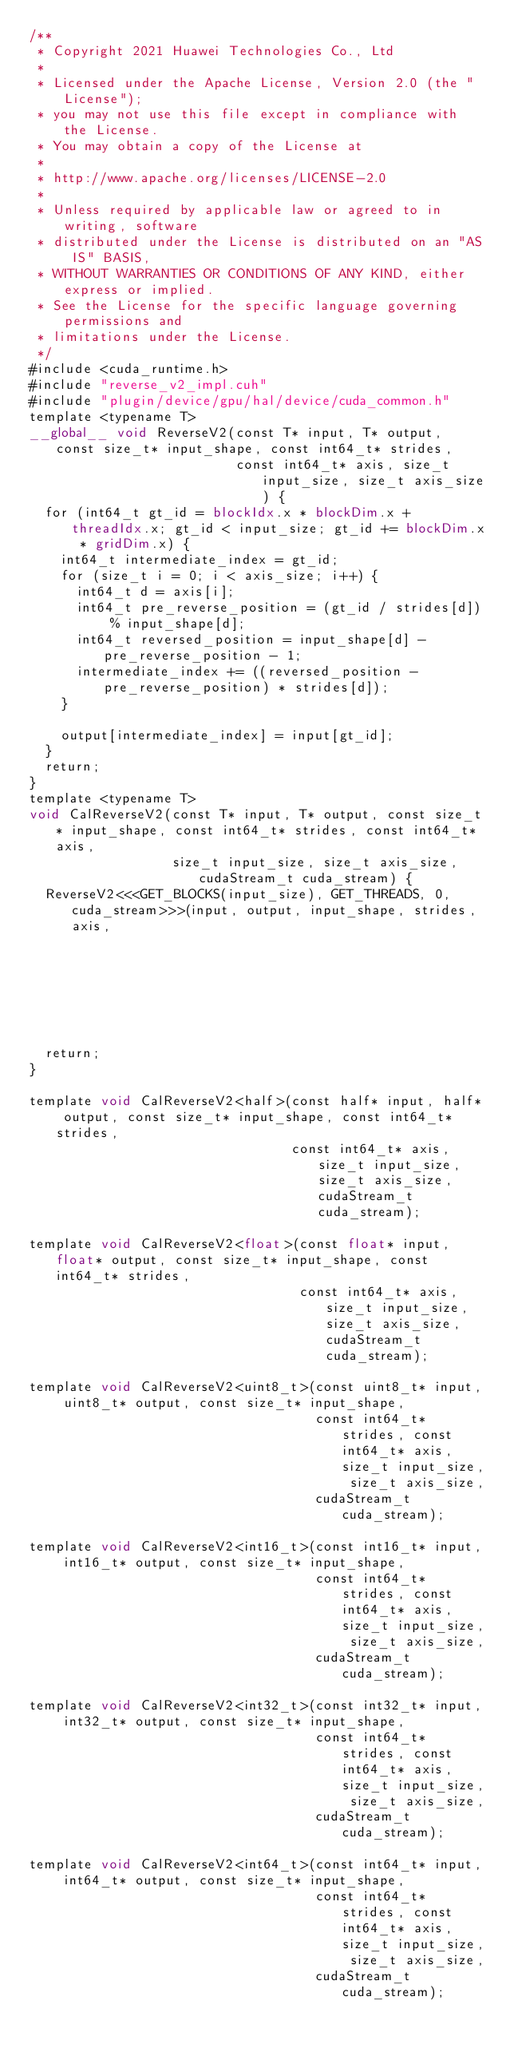Convert code to text. <code><loc_0><loc_0><loc_500><loc_500><_Cuda_>/**
 * Copyright 2021 Huawei Technologies Co., Ltd
 *
 * Licensed under the Apache License, Version 2.0 (the "License");
 * you may not use this file except in compliance with the License.
 * You may obtain a copy of the License at
 *
 * http://www.apache.org/licenses/LICENSE-2.0
 *
 * Unless required by applicable law or agreed to in writing, software
 * distributed under the License is distributed on an "AS IS" BASIS,
 * WITHOUT WARRANTIES OR CONDITIONS OF ANY KIND, either express or implied.
 * See the License for the specific language governing permissions and
 * limitations under the License.
 */
#include <cuda_runtime.h>
#include "reverse_v2_impl.cuh"
#include "plugin/device/gpu/hal/device/cuda_common.h"
template <typename T>
__global__ void ReverseV2(const T* input, T* output, const size_t* input_shape, const int64_t* strides,
                          const int64_t* axis, size_t input_size, size_t axis_size) {
  for (int64_t gt_id = blockIdx.x * blockDim.x + threadIdx.x; gt_id < input_size; gt_id += blockDim.x * gridDim.x) {
    int64_t intermediate_index = gt_id;
    for (size_t i = 0; i < axis_size; i++) {
      int64_t d = axis[i];
      int64_t pre_reverse_position = (gt_id / strides[d]) % input_shape[d];
      int64_t reversed_position = input_shape[d] - pre_reverse_position - 1;
      intermediate_index += ((reversed_position - pre_reverse_position) * strides[d]);
    }

    output[intermediate_index] = input[gt_id];
  }
  return;
}
template <typename T>
void CalReverseV2(const T* input, T* output, const size_t* input_shape, const int64_t* strides, const int64_t* axis,
                  size_t input_size, size_t axis_size, cudaStream_t cuda_stream) {
  ReverseV2<<<GET_BLOCKS(input_size), GET_THREADS, 0, cuda_stream>>>(input, output, input_shape, strides, axis,
                                                                     input_size, axis_size);
  return;
}

template void CalReverseV2<half>(const half* input, half* output, const size_t* input_shape, const int64_t* strides,
                                 const int64_t* axis, size_t input_size, size_t axis_size, cudaStream_t cuda_stream);

template void CalReverseV2<float>(const float* input, float* output, const size_t* input_shape, const int64_t* strides,
                                  const int64_t* axis, size_t input_size, size_t axis_size, cudaStream_t cuda_stream);

template void CalReverseV2<uint8_t>(const uint8_t* input, uint8_t* output, const size_t* input_shape,
                                    const int64_t* strides, const int64_t* axis, size_t input_size, size_t axis_size,
                                    cudaStream_t cuda_stream);

template void CalReverseV2<int16_t>(const int16_t* input, int16_t* output, const size_t* input_shape,
                                    const int64_t* strides, const int64_t* axis, size_t input_size, size_t axis_size,
                                    cudaStream_t cuda_stream);

template void CalReverseV2<int32_t>(const int32_t* input, int32_t* output, const size_t* input_shape,
                                    const int64_t* strides, const int64_t* axis, size_t input_size, size_t axis_size,
                                    cudaStream_t cuda_stream);

template void CalReverseV2<int64_t>(const int64_t* input, int64_t* output, const size_t* input_shape,
                                    const int64_t* strides, const int64_t* axis, size_t input_size, size_t axis_size,
                                    cudaStream_t cuda_stream);
</code> 